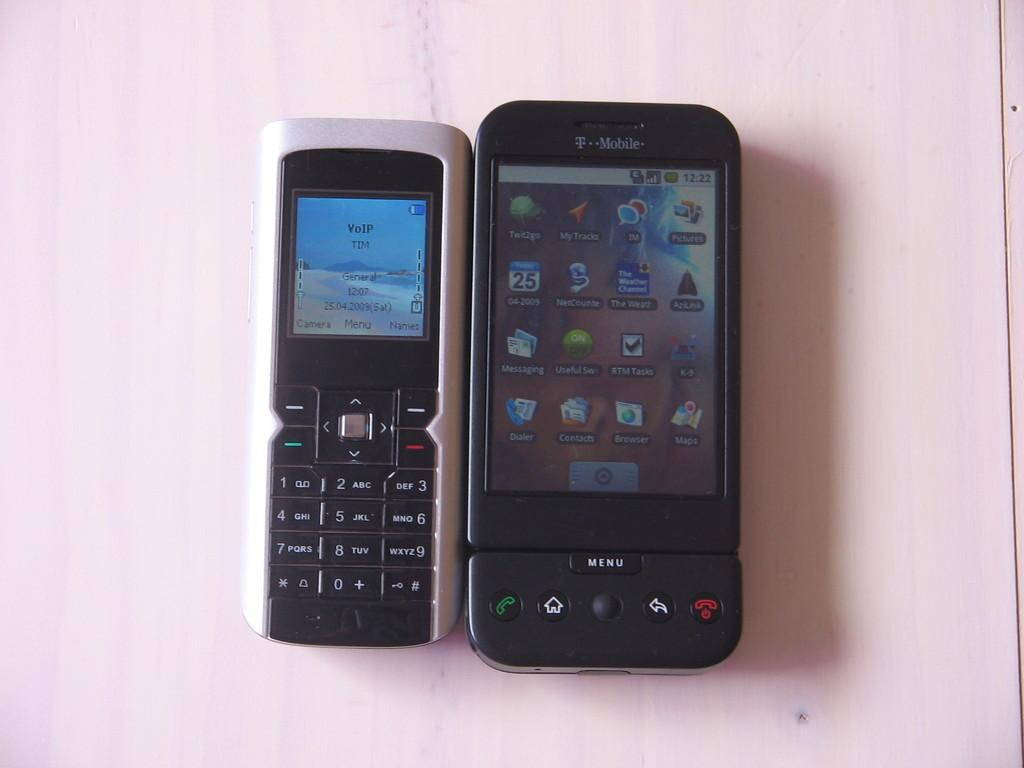<image>
Present a compact description of the photo's key features. A black T-Mobile phone next to another phone. 